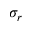<formula> <loc_0><loc_0><loc_500><loc_500>\sigma _ { r }</formula> 